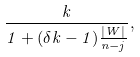Convert formula to latex. <formula><loc_0><loc_0><loc_500><loc_500>\frac { k } { 1 + ( \delta k - 1 ) \frac { | W | } { n - j } } ,</formula> 